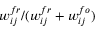<formula> <loc_0><loc_0><loc_500><loc_500>w _ { i j } ^ { f r } / ( w _ { i j } ^ { f r } + w _ { i j } ^ { f o } )</formula> 